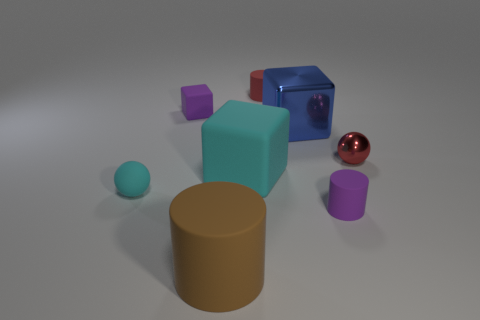There is a cylinder that is the same color as the metallic sphere; what is it made of?
Offer a terse response. Rubber. The cylinder that is the same color as the tiny metal sphere is what size?
Offer a very short reply. Small. How many large blue blocks are the same material as the tiny red ball?
Keep it short and to the point. 1. Is there a tiny red shiny sphere?
Offer a very short reply. Yes. There is a cylinder behind the tiny purple cylinder; what size is it?
Your response must be concise. Small. What number of metal spheres are the same color as the big matte block?
Offer a terse response. 0. What number of spheres are small purple things or big brown objects?
Ensure brevity in your answer.  0. There is a rubber object that is both behind the large blue metal thing and on the left side of the red rubber cylinder; what is its shape?
Keep it short and to the point. Cube. Are there any gray metallic things that have the same size as the rubber sphere?
Keep it short and to the point. No. What number of objects are large rubber objects that are behind the tiny purple cylinder or small purple objects?
Your answer should be very brief. 3. 